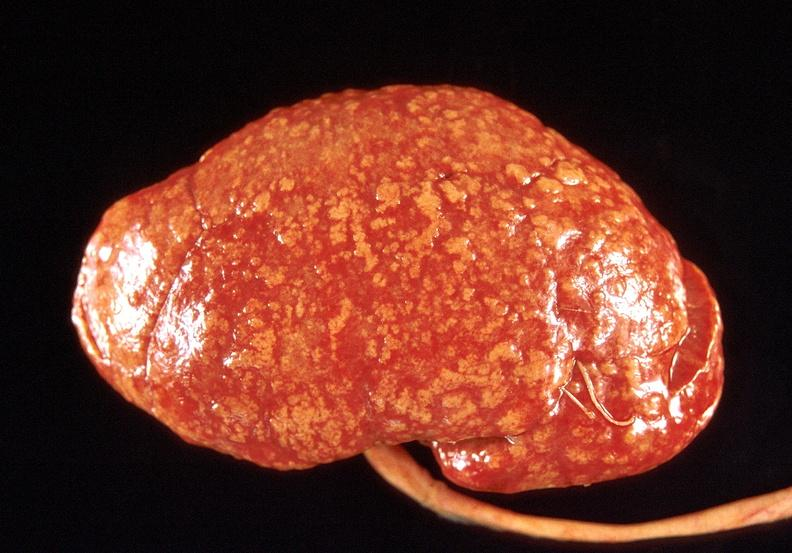does this image show kidney, obliterative endarteritis - sclerodema?
Answer the question using a single word or phrase. Yes 